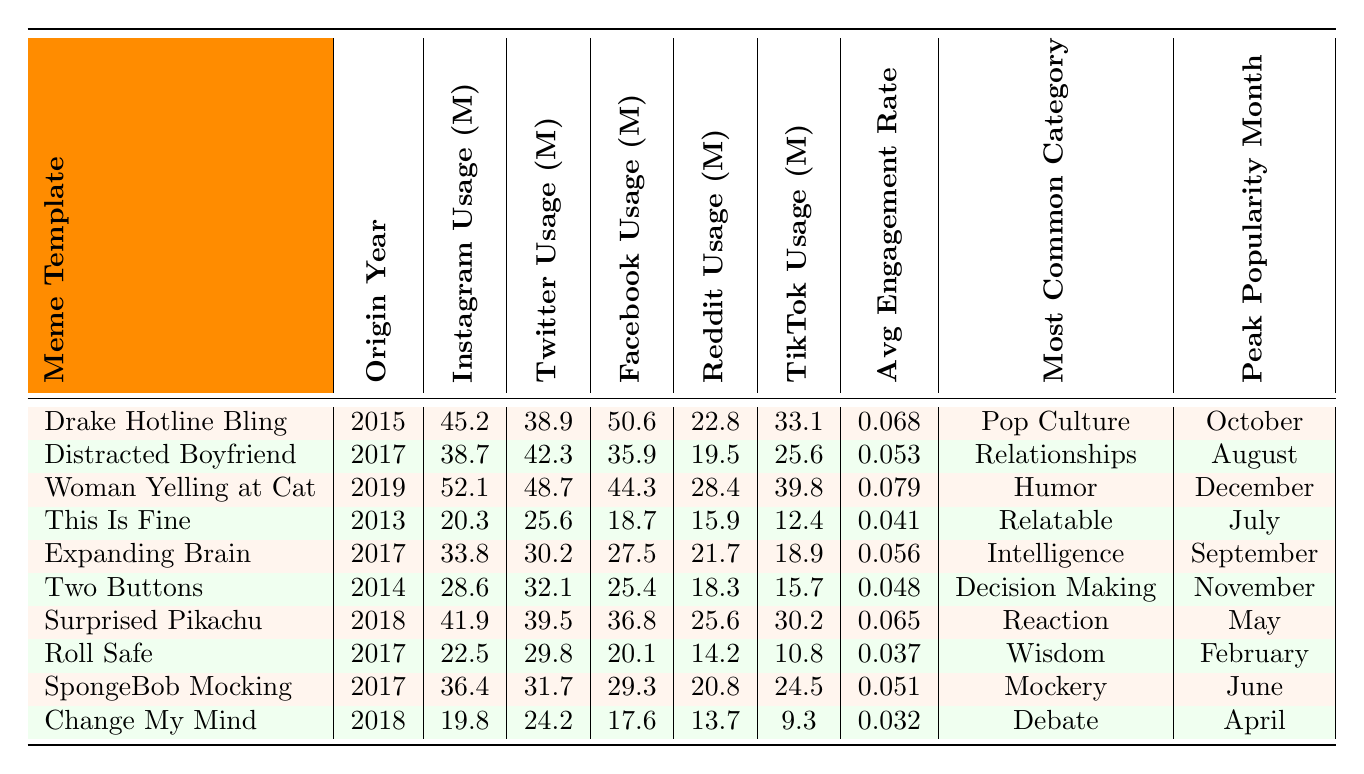What is the meme template with the highest Instagram usage? By checking the "Instagram Usage (millions)" column in the table, the highest value is 52.1, which corresponds to the "Woman Yelling at Cat" meme template.
Answer: Woman Yelling at Cat Which meme template has the lowest average engagement rate? The "Change My Mind" meme template has the lowest average engagement rate at 0.032, as seen in the "Average Engagement Rate" column.
Answer: Change My Mind What is the combined Facebook usage for the two most popular meme templates? The highest values for Facebook usage are 50.6 for "Drake Hotline Bling" and 44.3 for "Woman Yelling at Cat." The sum is 50.6 + 44.3 = 94.9 million.
Answer: 94.9 million Which meme templates were most popular in May and October? The "Surprised Pikachu" meme template peaked in May while the "Drake Hotline Bling" peaked in October. This information can be found in the "Peak Popularity Month" column.
Answer: Surprised Pikachu (May), Drake Hotline Bling (October) Is there a meme template from 2013 that has high usage on any platform? Yes, the "This Is Fine" meme template, which originated in 2013, shows usage on multiple platforms; for example, it has 20.3 million on Instagram, 25.6 million on Twitter, and 18.7 million on Facebook.
Answer: Yes What is the average TikTok usage for meme templates originating in 2017? There are three meme templates from 2017: "Distracted Boyfriend," "Expanding Brain," and "Roll Safe," which have TikTok usages of 25.6, 18.9, and 10.8 million respectively. The average is (25.6 + 18.9 + 10.8) / 3 = 18.43 million.
Answer: 18.43 million Which meme template is associated with the most common category of “Humor”? The "Woman Yelling at Cat" meme template falls under the "Humor" category according to the table, which can be found in the "Most Common Category" column.
Answer: Woman Yelling at Cat What year did the meme with the highest Twitter usage originate? "Woman Yelling at Cat" has the highest Twitter usage at 48.7 million, and it originated in 2019. This information can be found in the respective columns.
Answer: 2019 How many more million users did the "Drake Hotline Bling" have on Facebook compared to "Change My Mind"? The "Drake Hotline Bling" had 50.6 million Facebook users, and "Change My Mind" had 17.6 million. The difference is 50.6 - 17.6 = 33 million.
Answer: 33 million Which meme template has the highest usage across all platforms combined? After calculating the total usage for each meme template across all platforms, it is determined that "Woman Yelling at Cat" has the highest combined usage of (52.1 + 48.7 + 44.3 + 28.4 + 39.8 + 39.8 + 25.6 + 20.8 + 24.5 + 17.6) = 341.6 million.
Answer: Woman Yelling at Cat What is the peak popularity month for the meme template "Two Buttons"? The "Two Buttons" meme template has its peak popularity month in November, which is directly listed in the "Peak Popularity Month" column.
Answer: November 